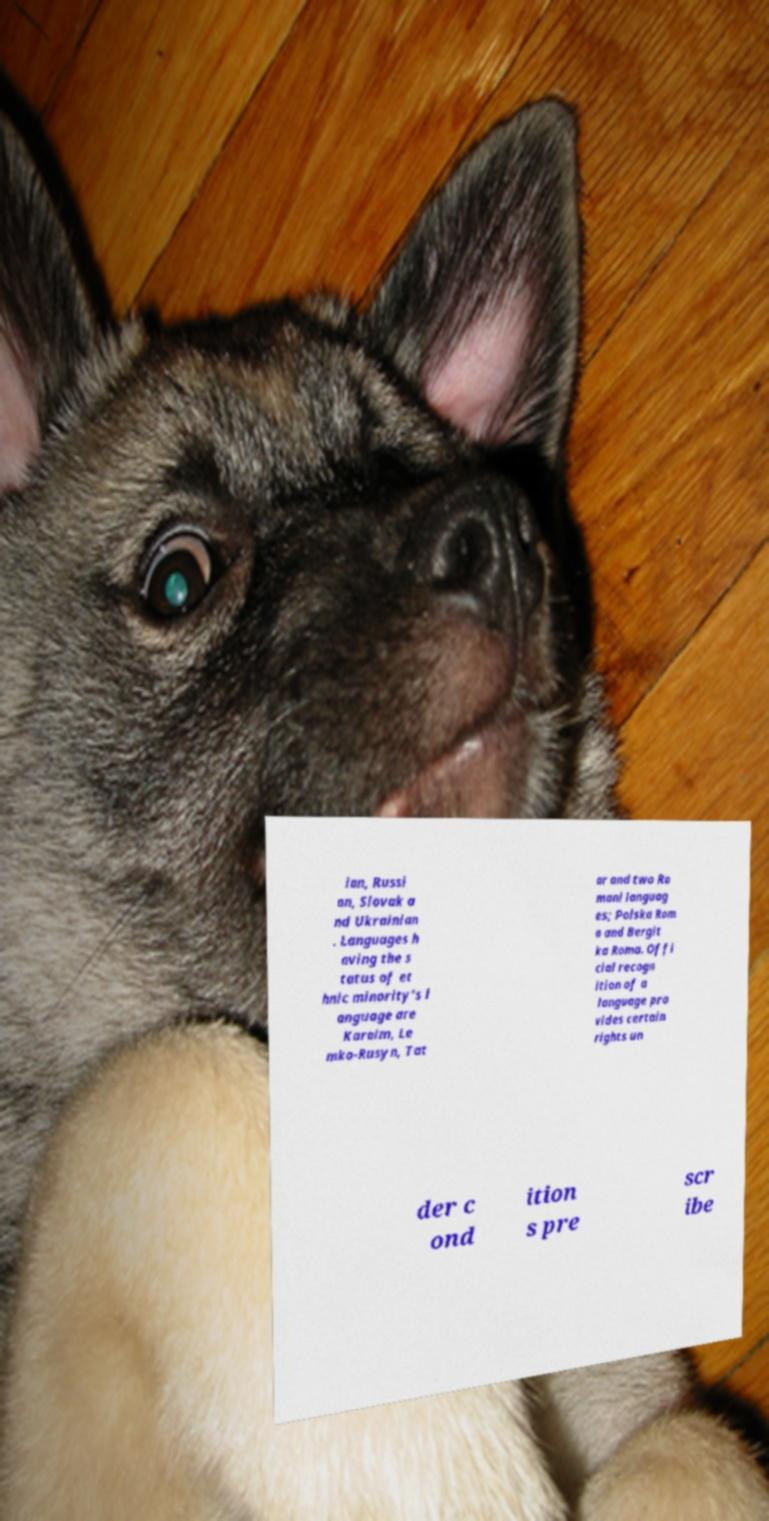I need the written content from this picture converted into text. Can you do that? ian, Russi an, Slovak a nd Ukrainian . Languages h aving the s tatus of et hnic minority's l anguage are Karaim, Le mko-Rusyn, Tat ar and two Ro mani languag es; Polska Rom a and Bergit ka Roma. Offi cial recogn ition of a language pro vides certain rights un der c ond ition s pre scr ibe 